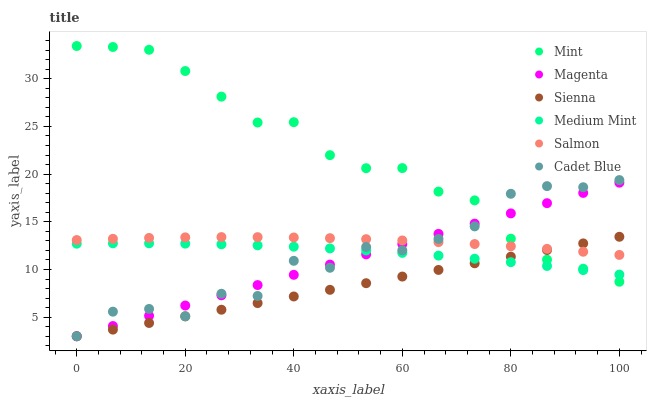Does Sienna have the minimum area under the curve?
Answer yes or no. Yes. Does Mint have the maximum area under the curve?
Answer yes or no. Yes. Does Cadet Blue have the minimum area under the curve?
Answer yes or no. No. Does Cadet Blue have the maximum area under the curve?
Answer yes or no. No. Is Magenta the smoothest?
Answer yes or no. Yes. Is Cadet Blue the roughest?
Answer yes or no. Yes. Is Salmon the smoothest?
Answer yes or no. No. Is Salmon the roughest?
Answer yes or no. No. Does Cadet Blue have the lowest value?
Answer yes or no. Yes. Does Salmon have the lowest value?
Answer yes or no. No. Does Mint have the highest value?
Answer yes or no. Yes. Does Cadet Blue have the highest value?
Answer yes or no. No. Is Medium Mint less than Salmon?
Answer yes or no. Yes. Is Salmon greater than Medium Mint?
Answer yes or no. Yes. Does Salmon intersect Sienna?
Answer yes or no. Yes. Is Salmon less than Sienna?
Answer yes or no. No. Is Salmon greater than Sienna?
Answer yes or no. No. Does Medium Mint intersect Salmon?
Answer yes or no. No. 